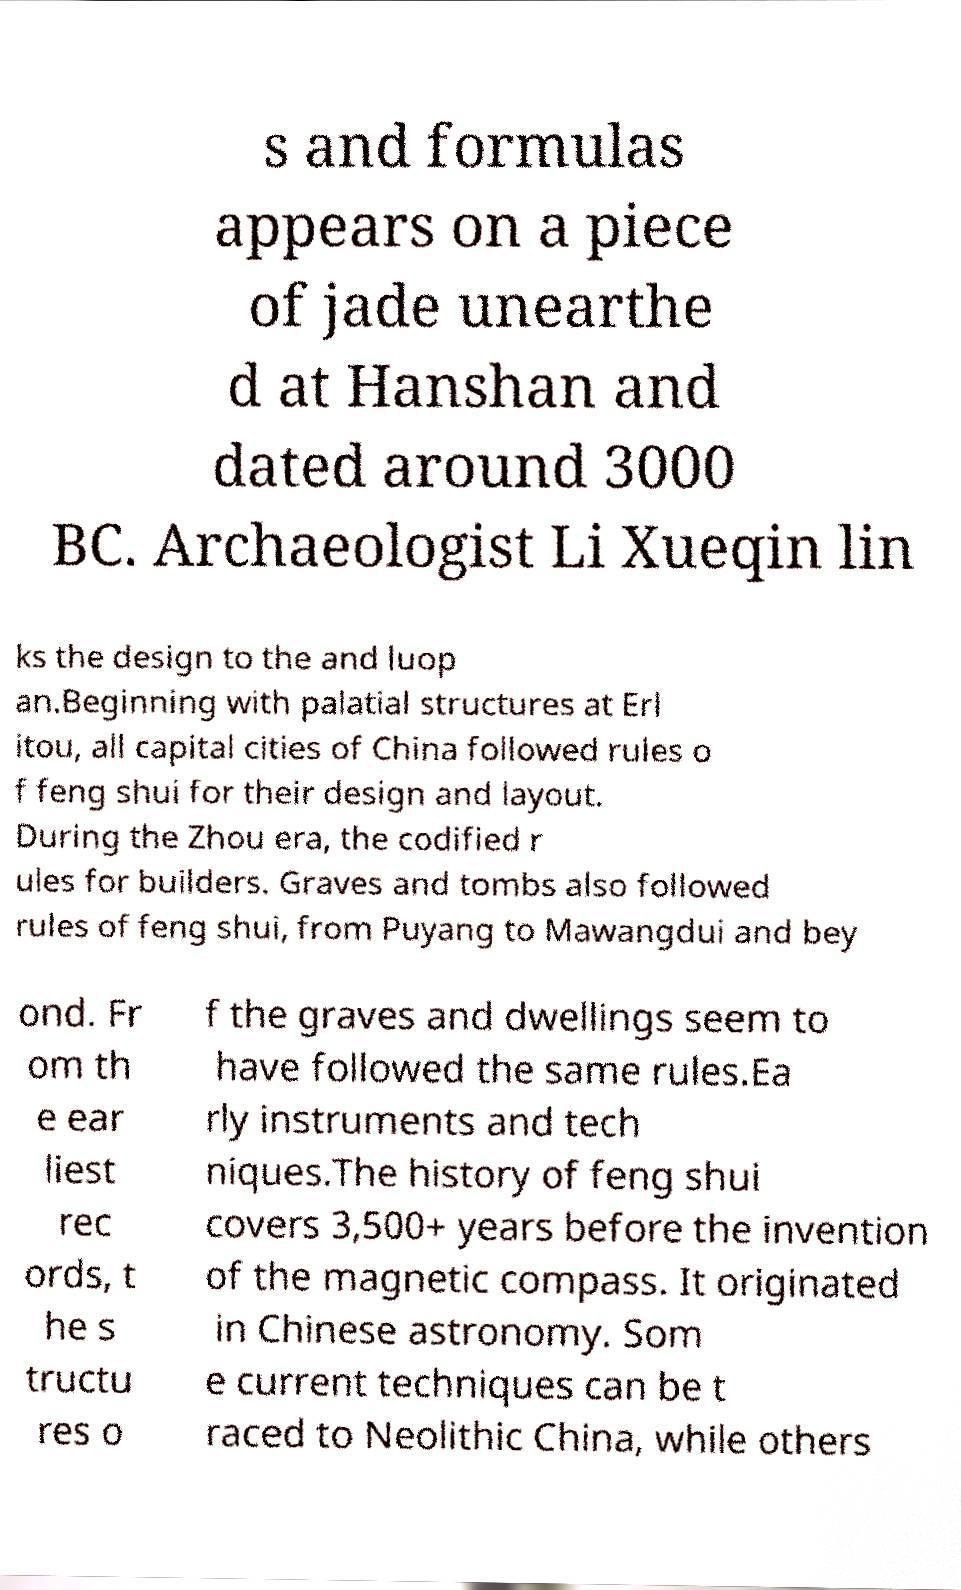Could you assist in decoding the text presented in this image and type it out clearly? s and formulas appears on a piece of jade unearthe d at Hanshan and dated around 3000 BC. Archaeologist Li Xueqin lin ks the design to the and luop an.Beginning with palatial structures at Erl itou, all capital cities of China followed rules o f feng shui for their design and layout. During the Zhou era, the codified r ules for builders. Graves and tombs also followed rules of feng shui, from Puyang to Mawangdui and bey ond. Fr om th e ear liest rec ords, t he s tructu res o f the graves and dwellings seem to have followed the same rules.Ea rly instruments and tech niques.The history of feng shui covers 3,500+ years before the invention of the magnetic compass. It originated in Chinese astronomy. Som e current techniques can be t raced to Neolithic China, while others 